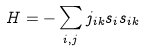Convert formula to latex. <formula><loc_0><loc_0><loc_500><loc_500>H = - \sum _ { i , j } j _ { i k } s _ { i } s _ { i k }</formula> 